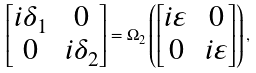<formula> <loc_0><loc_0><loc_500><loc_500>\begin{bmatrix} i \delta _ { 1 } & 0 \\ 0 & i \delta _ { 2 } \end{bmatrix} = \Omega _ { 2 } \left ( \begin{bmatrix} i \varepsilon & 0 \\ 0 & i \varepsilon \end{bmatrix} \right ) ,</formula> 